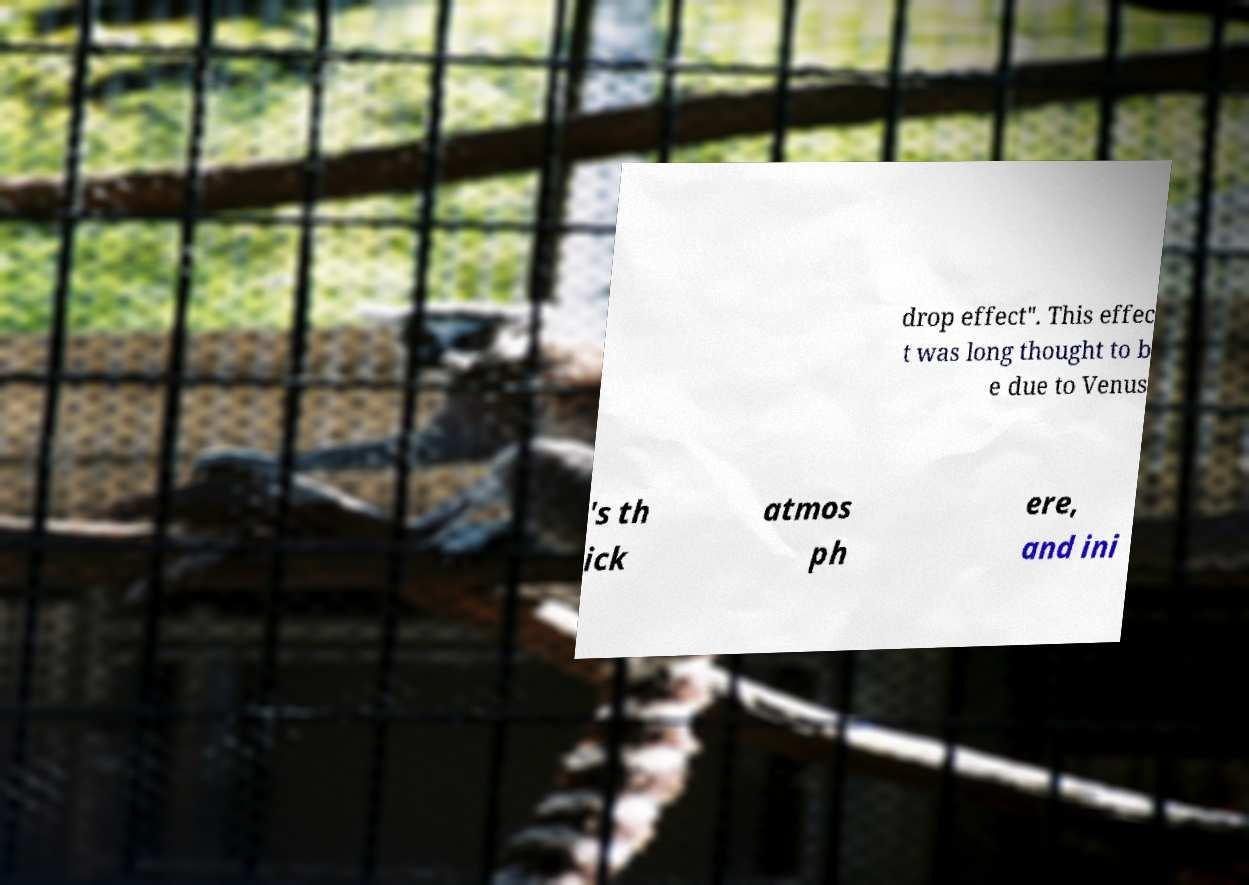Please identify and transcribe the text found in this image. drop effect". This effec t was long thought to b e due to Venus 's th ick atmos ph ere, and ini 